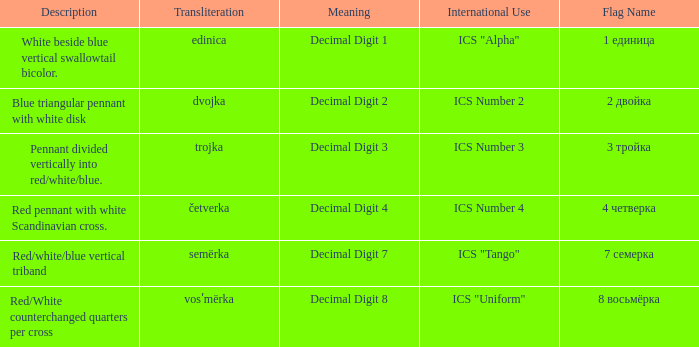What is the name of the flag that means decimal digit 2? 2 двойка. 